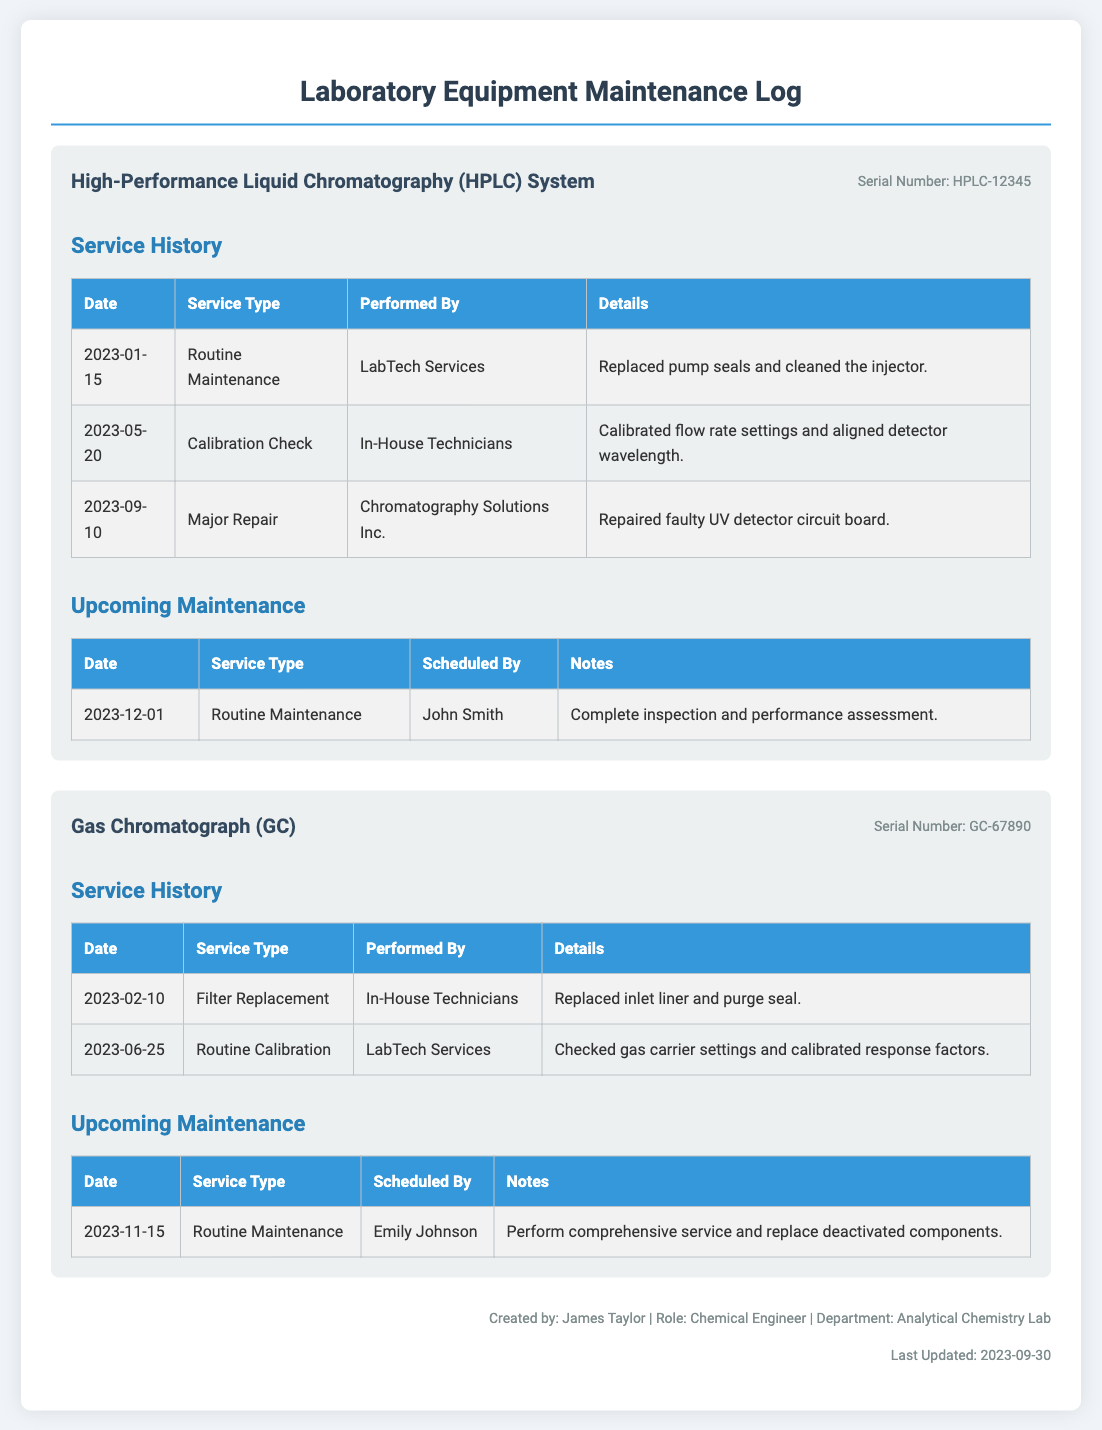What is the serial number of the HPLC system? The serial number is listed directly under the instrument name in the document.
Answer: HPLC-12345 Who performed the major repair on the HPLC system? The document specifies who performed each service, and for the major repair, it states the company that handled it.
Answer: Chromatography Solutions Inc When is the next routine maintenance scheduled for the Gas Chromatograph? The upcoming maintenance table lists all scheduled maintenance dates for each instrument.
Answer: 2023-11-15 What type of service was conducted on the HPLC system on January 15, 2023? The service history section provides details about the dates and types of services performed.
Answer: Routine Maintenance Which technician scheduled the upcoming maintenance for the HPLC system? The scheduled maintenance section indicates who is responsible for the upcoming service for each instrument.
Answer: John Smith What was replaced during the February 10 service for the Gas Chromatograph? The details of services performed often list specific parts replaced or repaired.
Answer: Inlet liner and purge seal How many major repairs have been documented for the HPLC system? The service history outlines different types of maintenance and repairs, so counting them is straightforward.
Answer: 1 What is the role of the person who created the log? The creator's role is mentioned in the footer of the document, which typically includes information about the author.
Answer: Chemical Engineer What color is the table header for the service history section? The styles specified in the document define the color of the table headers.
Answer: Blue 